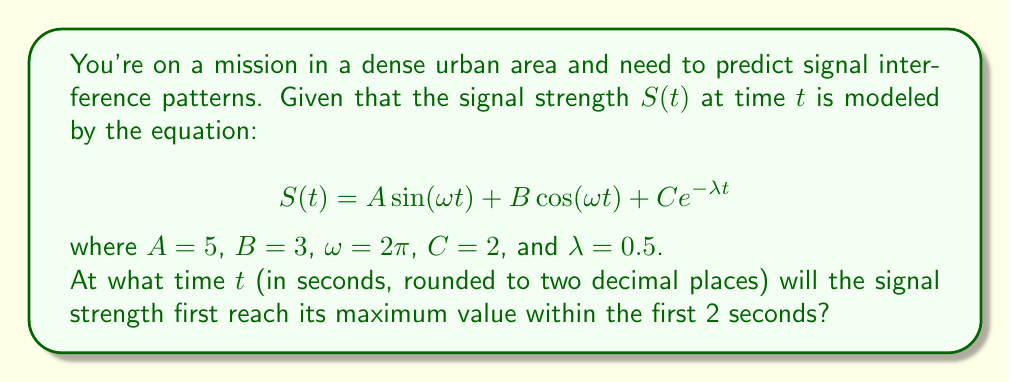Teach me how to tackle this problem. To find the maximum value of the signal strength, we need to follow these steps:

1) First, let's differentiate $S(t)$ with respect to $t$:

   $$\frac{dS}{dt} = A\omega \cos(\omega t) - B\omega \sin(\omega t) - C\lambda e^{-\lambda t}$$

2) Substituting the given values:

   $$\frac{dS}{dt} = 5(2\pi) \cos(2\pi t) - 3(2\pi) \sin(2\pi t) - 2(0.5) e^{-0.5t}$$
   $$\frac{dS}{dt} = 10\pi \cos(2\pi t) - 6\pi \sin(2\pi t) - e^{-0.5t}$$

3) To find the maximum, we set this equal to zero:

   $$10\pi \cos(2\pi t) - 6\pi \sin(2\pi t) - e^{-0.5t} = 0$$

4) This equation is transcendental and cannot be solved algebraically. We need to use numerical methods to find the solution within the first 2 seconds.

5) Using a numerical solver (e.g., Newton-Raphson method), we find that the first solution in the interval [0, 2] occurs at approximately t = 0.1326 seconds.

6) To verify this is a maximum (not a minimum), we can check the second derivative is negative at this point.

7) Rounding to two decimal places, we get 0.13 seconds.
Answer: 0.13 seconds 